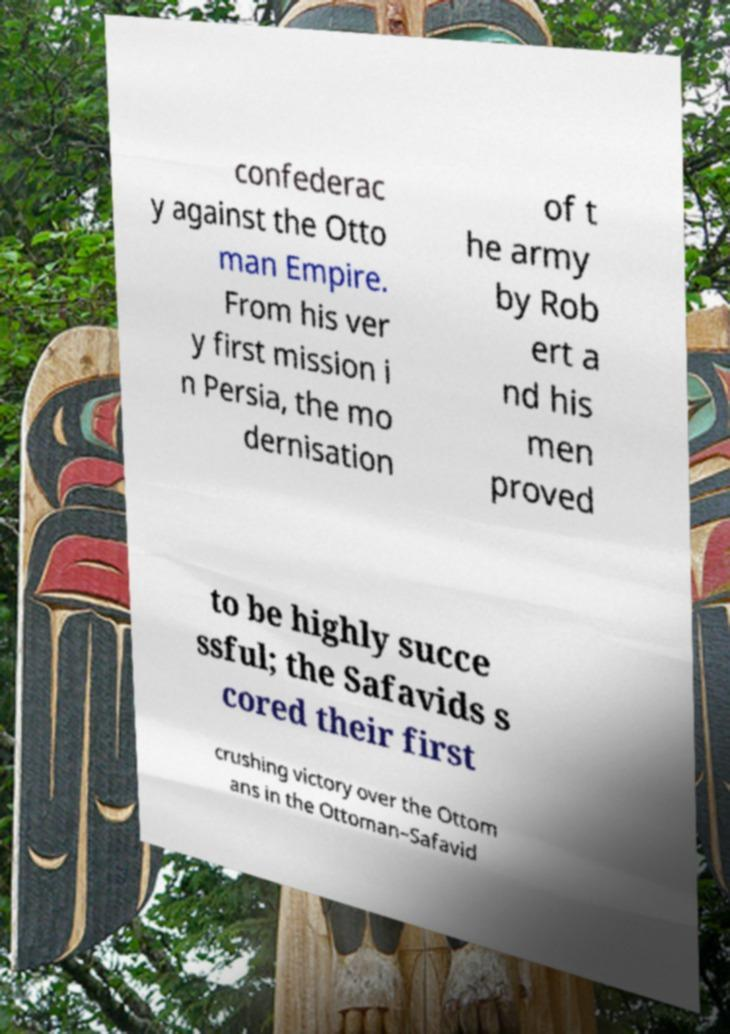There's text embedded in this image that I need extracted. Can you transcribe it verbatim? confederac y against the Otto man Empire. From his ver y first mission i n Persia, the mo dernisation of t he army by Rob ert a nd his men proved to be highly succe ssful; the Safavids s cored their first crushing victory over the Ottom ans in the Ottoman–Safavid 